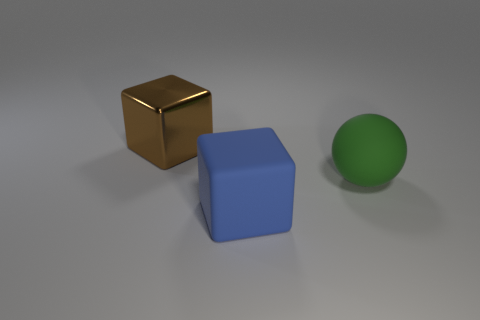Are there any other things that have the same material as the brown thing?
Your answer should be compact. No. What is the shape of the blue matte thing that is the same size as the metallic cube?
Give a very brief answer. Cube. What color is the large block in front of the brown metallic block?
Provide a short and direct response. Blue. Is there a ball behind the large cube behind the blue object?
Your answer should be compact. No. How many objects are large things to the right of the brown cube or metal objects?
Your answer should be very brief. 3. There is a big cube on the right side of the block behind the blue rubber thing; what is its material?
Your response must be concise. Rubber. Are there an equal number of big matte objects in front of the blue rubber object and big rubber objects to the left of the green sphere?
Provide a succinct answer. No. How many things are either large green objects that are in front of the brown shiny thing or big matte objects behind the blue matte cube?
Offer a terse response. 1. There is a large object that is both left of the green ball and behind the blue matte object; what is its material?
Provide a short and direct response. Metal. Are there more brown shiny objects than yellow cylinders?
Keep it short and to the point. Yes. 